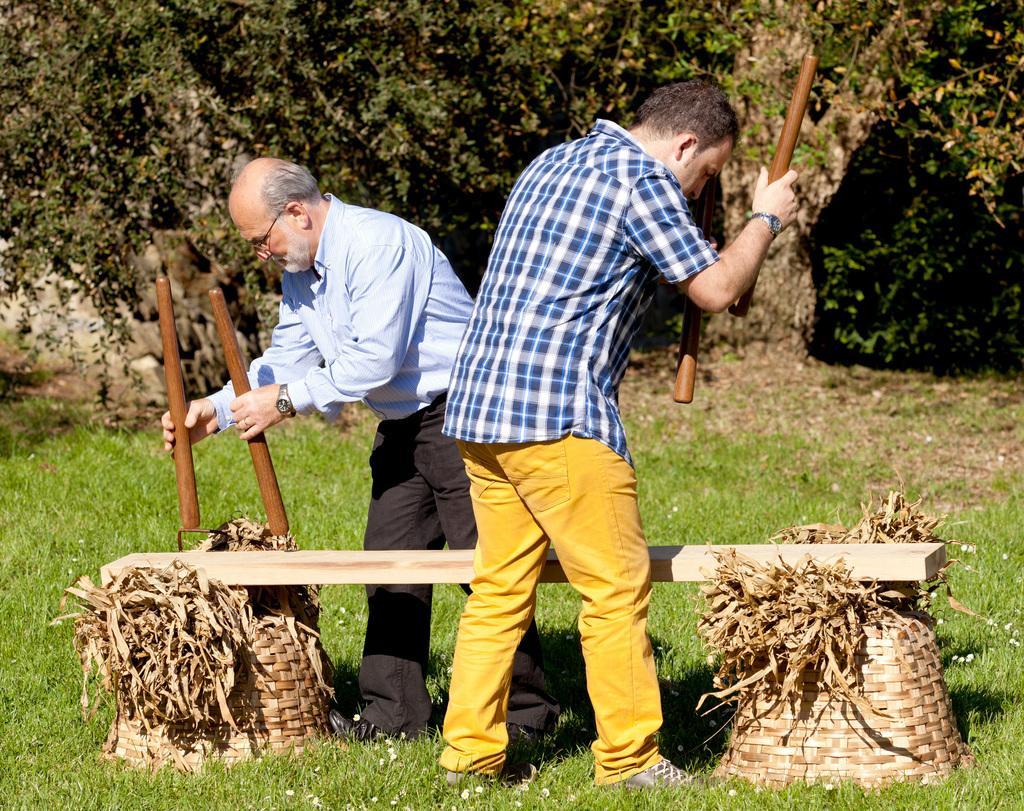How would you summarize this image in a sentence or two? This is the picture of two people who are holding some sticks and standing in front of the thing which has two baskets on the grass floor and around there are some trees and plants. 